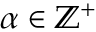Convert formula to latex. <formula><loc_0><loc_0><loc_500><loc_500>\alpha \in \mathbb { Z } ^ { + }</formula> 